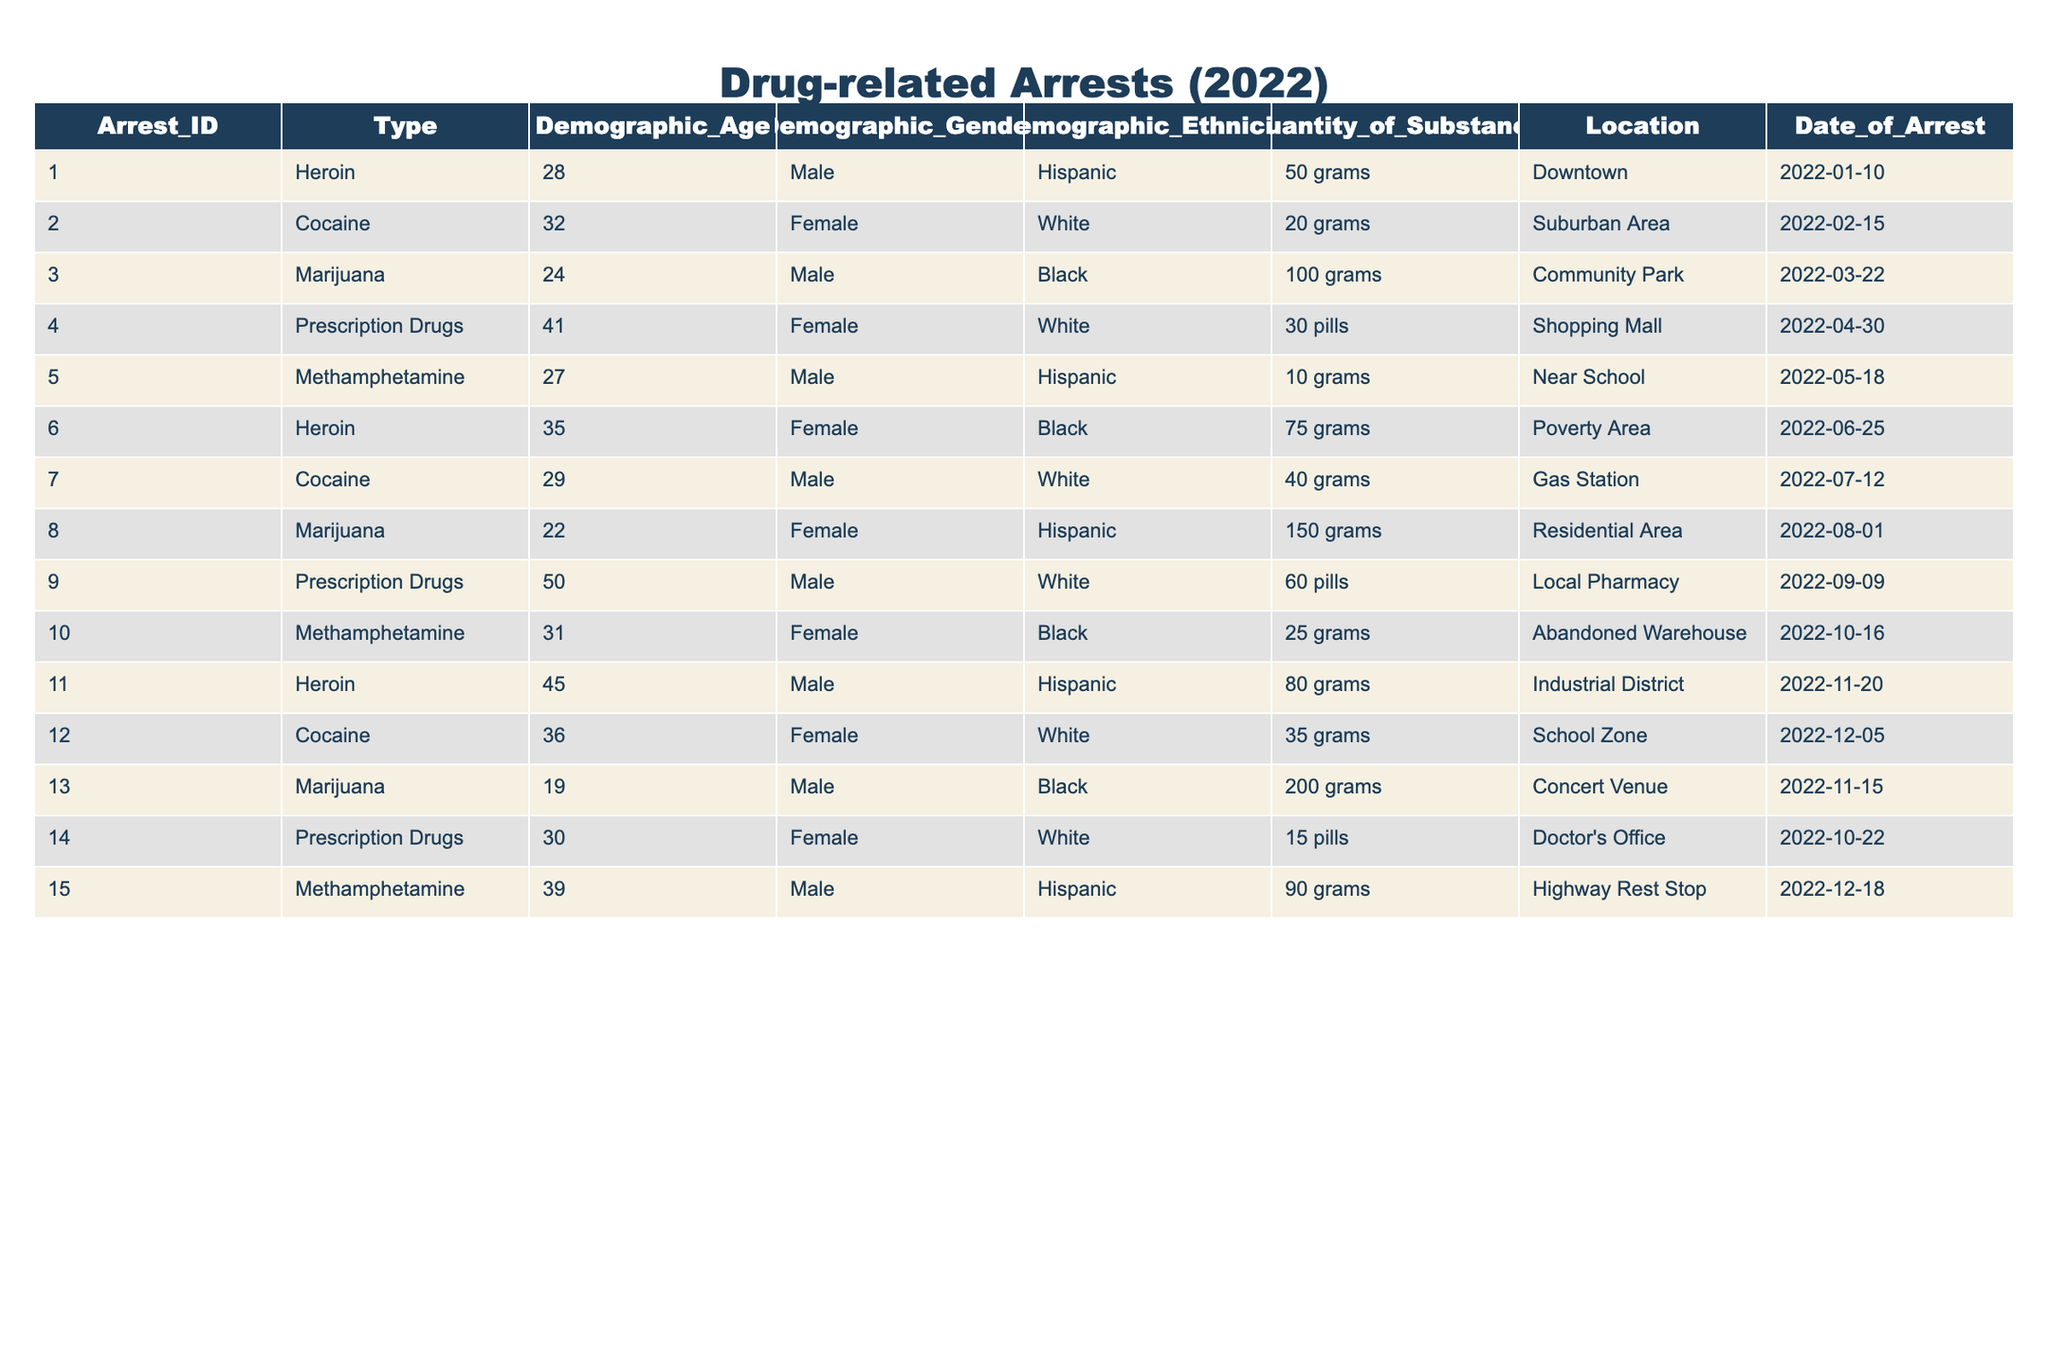What is the total number of drug-related arrests for Heroin? To find the answer, we look for all rows in the table where the Type is "Heroin". There are three entries: Arrest_IDs 001, 006, and 011. Thus, the total number of Heroin arrests is 3.
Answer: 3 How many Female arrests were made for Methamphetamine? Examining the rows where the Type is "Methamphetamine", we find two entries: Arrest_IDs 005 and 010. Out of these, Arrest_ID 010 has a Female demographic, indicating that there was 1 Female arrest for Methamphetamine.
Answer: 1 Is there any arrest recorded for Prescription Drugs involving individuals aged 50 or older? Looking at the rows where the Type is "Prescription Drugs", we see Arrest_ID 009, where the demographic age is 50. This indicates that there is indeed one arrest for Prescription Drugs involving an individual aged 50 or older.
Answer: Yes What is the average age of individuals arrested for Cocaine? First, identify all arrests related to Cocaine. There are three entries: Arrest_IDs 002, 007, and 012, with ages 32, 29, and 36 respectively. Adding these ages gives a total of 97, and since there are 3 individuals, the average age is 97 divided by 3, which equals approximately 32.33.
Answer: 32.33 Did any arrests for Marijuana occur in the Residential Area? Looking through the table, we check rows where the Type is "Marijuana" and the Location is "Residential Area". We find Arrest_ID 008 matches this criterion, confirming that there was indeed an arrest for Marijuana in the Residential Area.
Answer: Yes How many different types of drugs were involved in arrests across different locations? By scanning the table, we see that the types of drugs are Heroin, Cocaine, Marijuana, Prescription Drugs, and Methamphetamine. This accounts for a total of 5 different types of drugs involved in arrests across various locations.
Answer: 5 What is the quantity of substance seized in the arrest involving the oldest individual? Identifying the oldest individual in the demographic column gives us Arrest_ID 009 with an age of 50, related to Prescription Drugs, involving a seizure of 60 pills. Thus, the quantity of substance for the oldest individual is 60 pills.
Answer: 60 pills How many Male arrests involved more than 70 grams of Heroin? Filtering for arrests involving Heroin and Male individuals, we have Arrest_IDs 001 (50 grams) and 011 (80 grams). Here, only Arrest_ID 011 exceeds 70 grams, leading to a total of 1 Male arrest involving more than 70 grams of Heroin.
Answer: 1 What is the demographic ethnicity breakdown for individuals arrested for Methamphetamine? Checking the arrests made for Methamphetamine, we find the following demographic ethnicities: Arrest_ID 005 has Hispanic and Arrest_ID 010 is Black. Therefore, there are 1 Hispanic and 1 Black individuals arrested for Methamphetamine, representing an ethnicity breakdown of 1 Hispanic and 1 Black.
Answer: 1 Hispanic, 1 Black 